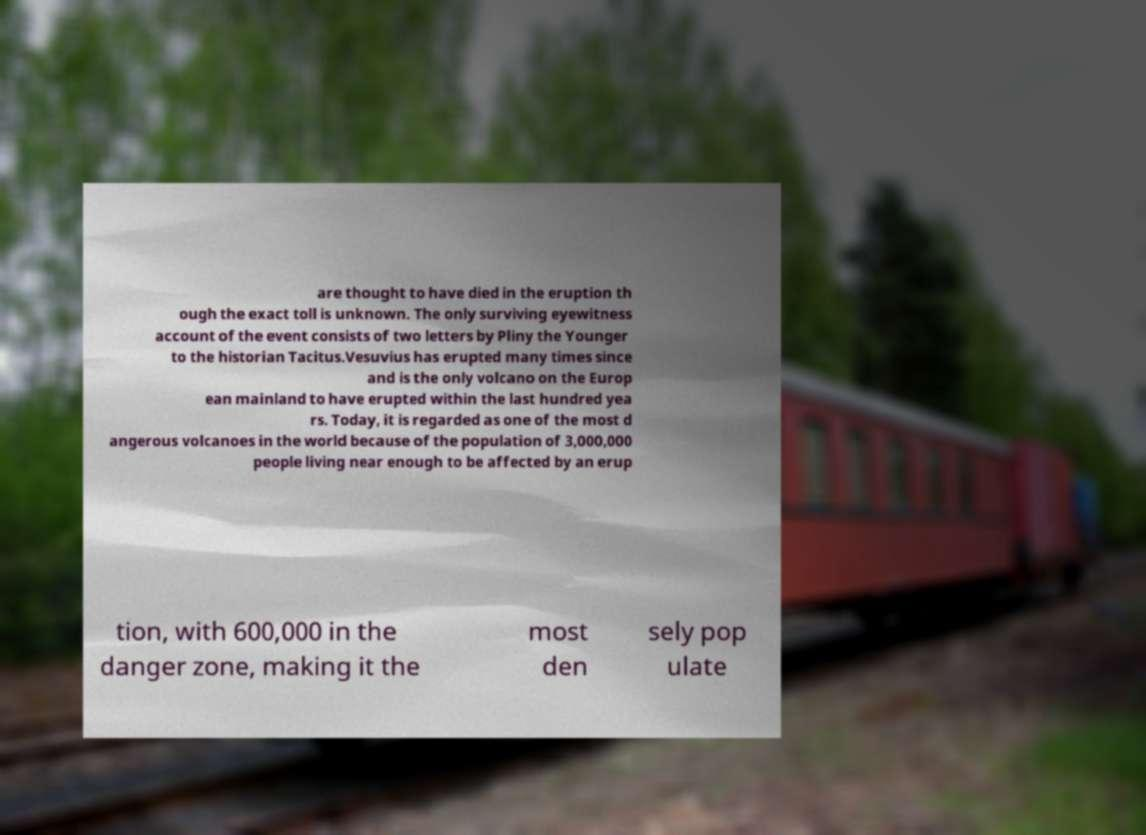Could you assist in decoding the text presented in this image and type it out clearly? are thought to have died in the eruption th ough the exact toll is unknown. The only surviving eyewitness account of the event consists of two letters by Pliny the Younger to the historian Tacitus.Vesuvius has erupted many times since and is the only volcano on the Europ ean mainland to have erupted within the last hundred yea rs. Today, it is regarded as one of the most d angerous volcanoes in the world because of the population of 3,000,000 people living near enough to be affected by an erup tion, with 600,000 in the danger zone, making it the most den sely pop ulate 